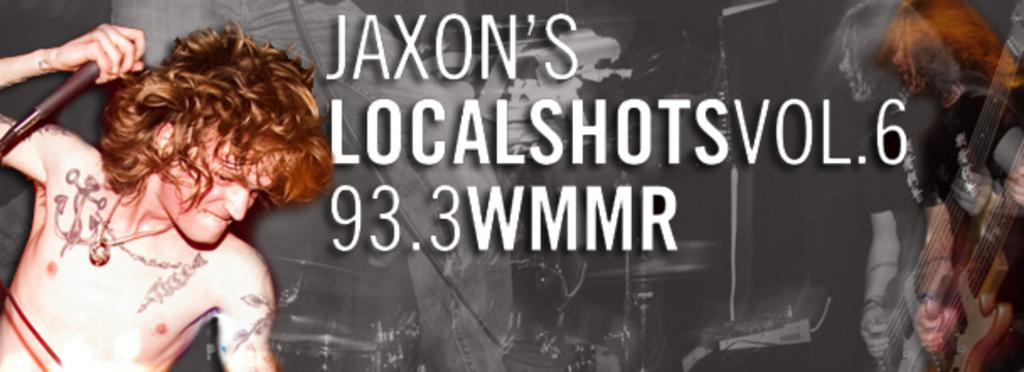What is happening in the poster? The poster contains a person standing and playing guitar, and another person holding a microphone. What are the people in the poster doing? They are playing music together, with one person playing the guitar and the other holding a microphone. What else can be seen on the poster besides the people? There are letters on the poster. What type of air is being used to power the vessel in the poster? There is no vessel or air present in the poster; it features two people playing music. What color is the stocking worn by the person holding the microphone? There is no stocking visible on the person holding the microphone in the poster. 